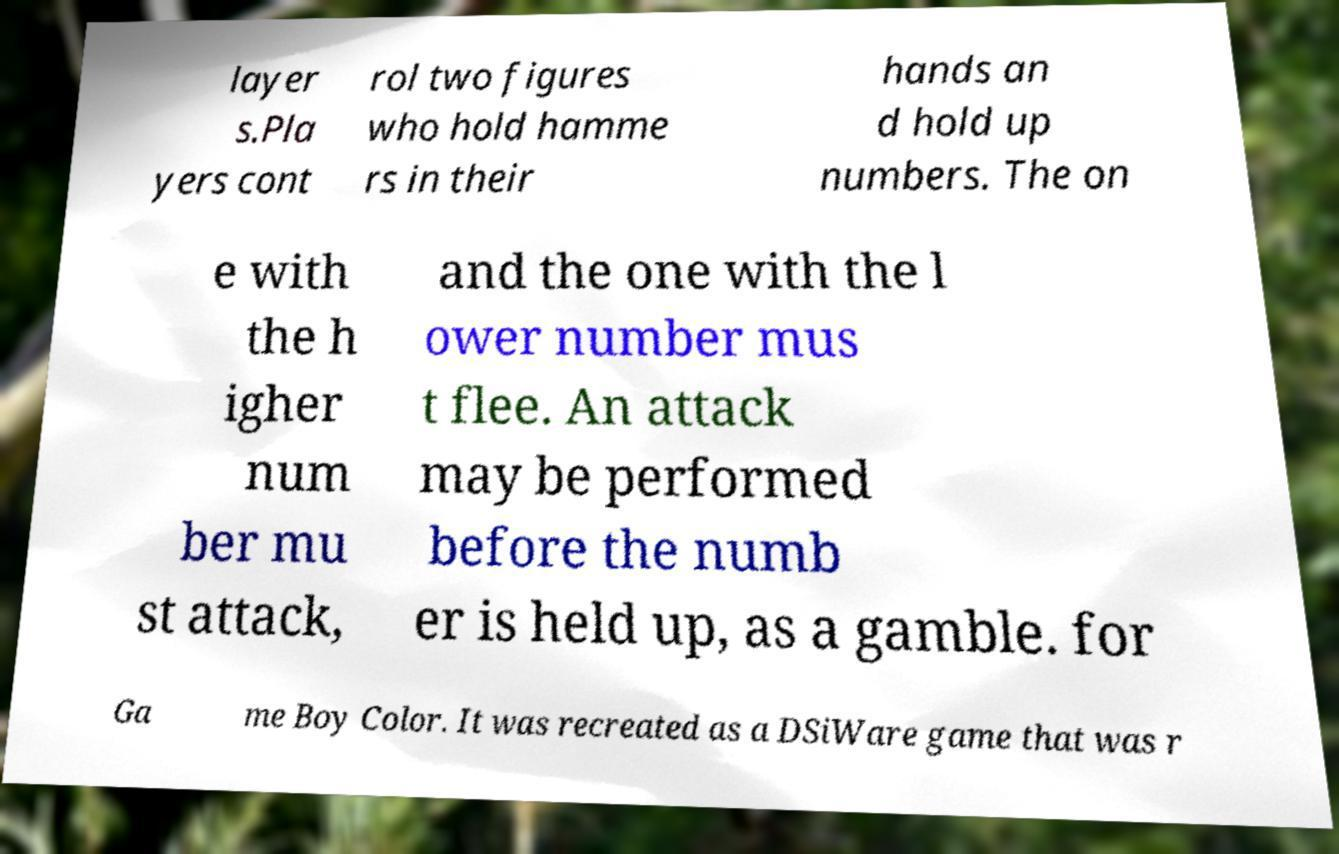Can you read and provide the text displayed in the image?This photo seems to have some interesting text. Can you extract and type it out for me? layer s.Pla yers cont rol two figures who hold hamme rs in their hands an d hold up numbers. The on e with the h igher num ber mu st attack, and the one with the l ower number mus t flee. An attack may be performed before the numb er is held up, as a gamble. for Ga me Boy Color. It was recreated as a DSiWare game that was r 